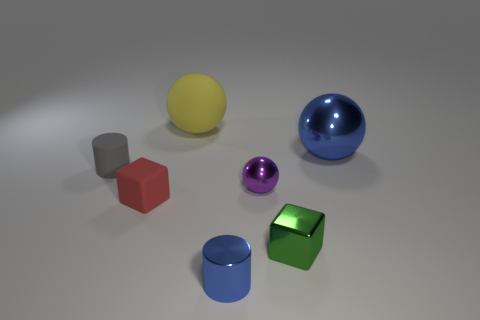Is the tiny shiny ball the same color as the tiny shiny block?
Give a very brief answer. No. Does the metallic object that is behind the gray matte cylinder have the same shape as the tiny purple thing?
Keep it short and to the point. Yes. What number of small objects are behind the red rubber cube and to the left of the purple shiny object?
Your answer should be very brief. 1. What material is the small gray cylinder?
Your response must be concise. Rubber. Is there anything else that has the same color as the rubber sphere?
Provide a succinct answer. No. Do the purple sphere and the yellow object have the same material?
Provide a succinct answer. No. There is a tiny purple thing on the left side of the shiny sphere to the right of the tiny purple object; what number of cylinders are to the right of it?
Offer a terse response. 0. How many big red matte spheres are there?
Offer a very short reply. 0. Is the number of matte spheres to the right of the small purple metal sphere less than the number of big yellow things in front of the tiny blue cylinder?
Keep it short and to the point. No. Are there fewer tiny rubber cylinders that are in front of the small matte cylinder than rubber balls?
Your answer should be very brief. Yes. 